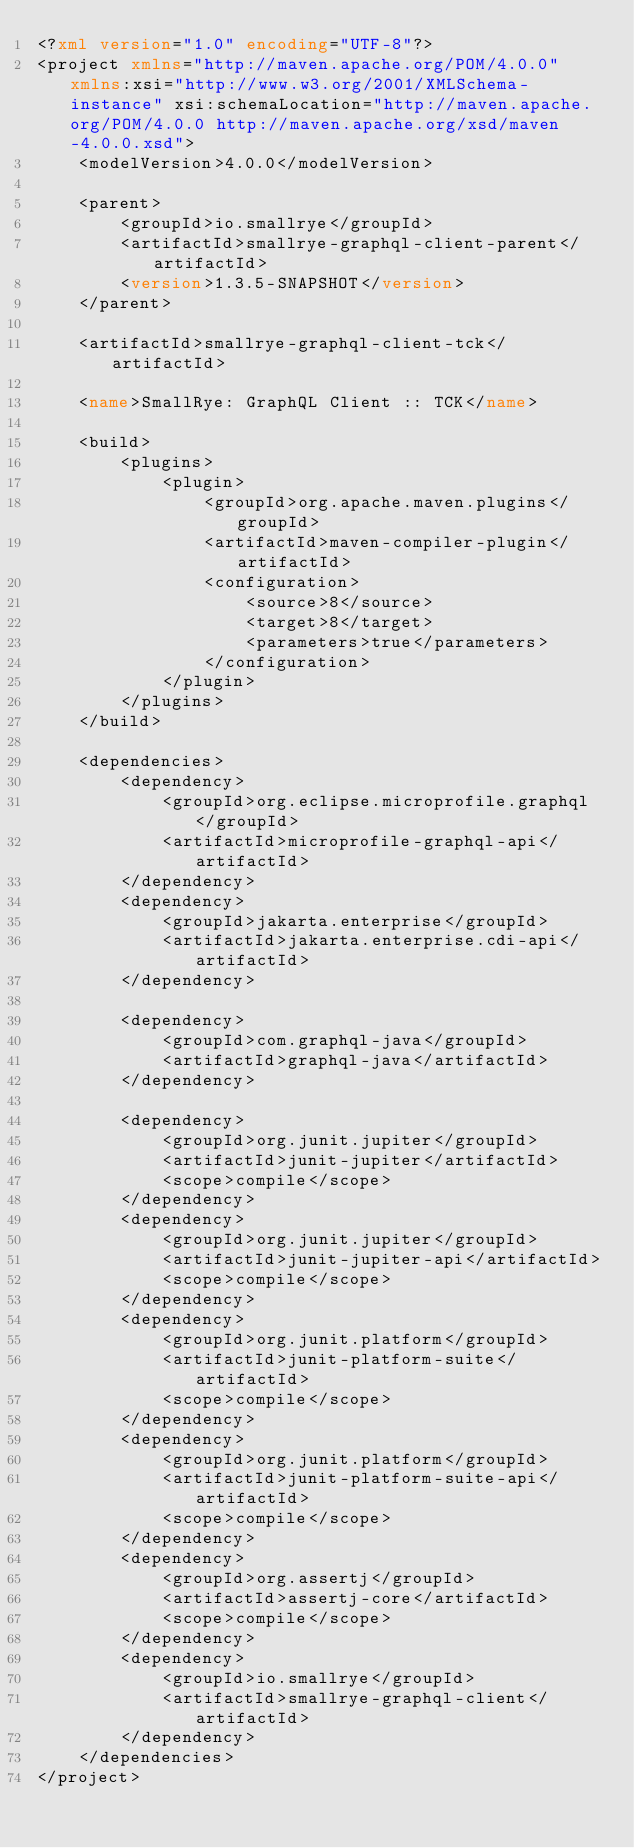<code> <loc_0><loc_0><loc_500><loc_500><_XML_><?xml version="1.0" encoding="UTF-8"?>
<project xmlns="http://maven.apache.org/POM/4.0.0" xmlns:xsi="http://www.w3.org/2001/XMLSchema-instance" xsi:schemaLocation="http://maven.apache.org/POM/4.0.0 http://maven.apache.org/xsd/maven-4.0.0.xsd">
    <modelVersion>4.0.0</modelVersion>

    <parent>
        <groupId>io.smallrye</groupId>
        <artifactId>smallrye-graphql-client-parent</artifactId>
        <version>1.3.5-SNAPSHOT</version>
    </parent>

    <artifactId>smallrye-graphql-client-tck</artifactId>

    <name>SmallRye: GraphQL Client :: TCK</name>

    <build>
        <plugins>
            <plugin>
                <groupId>org.apache.maven.plugins</groupId>
                <artifactId>maven-compiler-plugin</artifactId>
                <configuration>
                    <source>8</source>
                    <target>8</target>
                    <parameters>true</parameters>
                </configuration>
            </plugin>
        </plugins>
    </build>

    <dependencies>
        <dependency>
            <groupId>org.eclipse.microprofile.graphql</groupId>
            <artifactId>microprofile-graphql-api</artifactId>
        </dependency>
        <dependency>
            <groupId>jakarta.enterprise</groupId>
            <artifactId>jakarta.enterprise.cdi-api</artifactId>
        </dependency>

        <dependency>
            <groupId>com.graphql-java</groupId>
            <artifactId>graphql-java</artifactId>
        </dependency>

        <dependency>
            <groupId>org.junit.jupiter</groupId>
            <artifactId>junit-jupiter</artifactId>
            <scope>compile</scope>
        </dependency>
        <dependency>
            <groupId>org.junit.jupiter</groupId>
            <artifactId>junit-jupiter-api</artifactId>
            <scope>compile</scope>
        </dependency>
        <dependency>
            <groupId>org.junit.platform</groupId>
            <artifactId>junit-platform-suite</artifactId>
            <scope>compile</scope>
        </dependency>
        <dependency>
            <groupId>org.junit.platform</groupId>
            <artifactId>junit-platform-suite-api</artifactId>
            <scope>compile</scope>
        </dependency>
        <dependency>
            <groupId>org.assertj</groupId>
            <artifactId>assertj-core</artifactId>
            <scope>compile</scope>
        </dependency>
        <dependency>
            <groupId>io.smallrye</groupId>
            <artifactId>smallrye-graphql-client</artifactId>
        </dependency>
    </dependencies>
</project>
</code> 